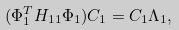<formula> <loc_0><loc_0><loc_500><loc_500>( \Phi _ { 1 } ^ { T } H _ { 1 1 } \Phi _ { 1 } ) C _ { 1 } = C _ { 1 } \Lambda _ { 1 } ,</formula> 